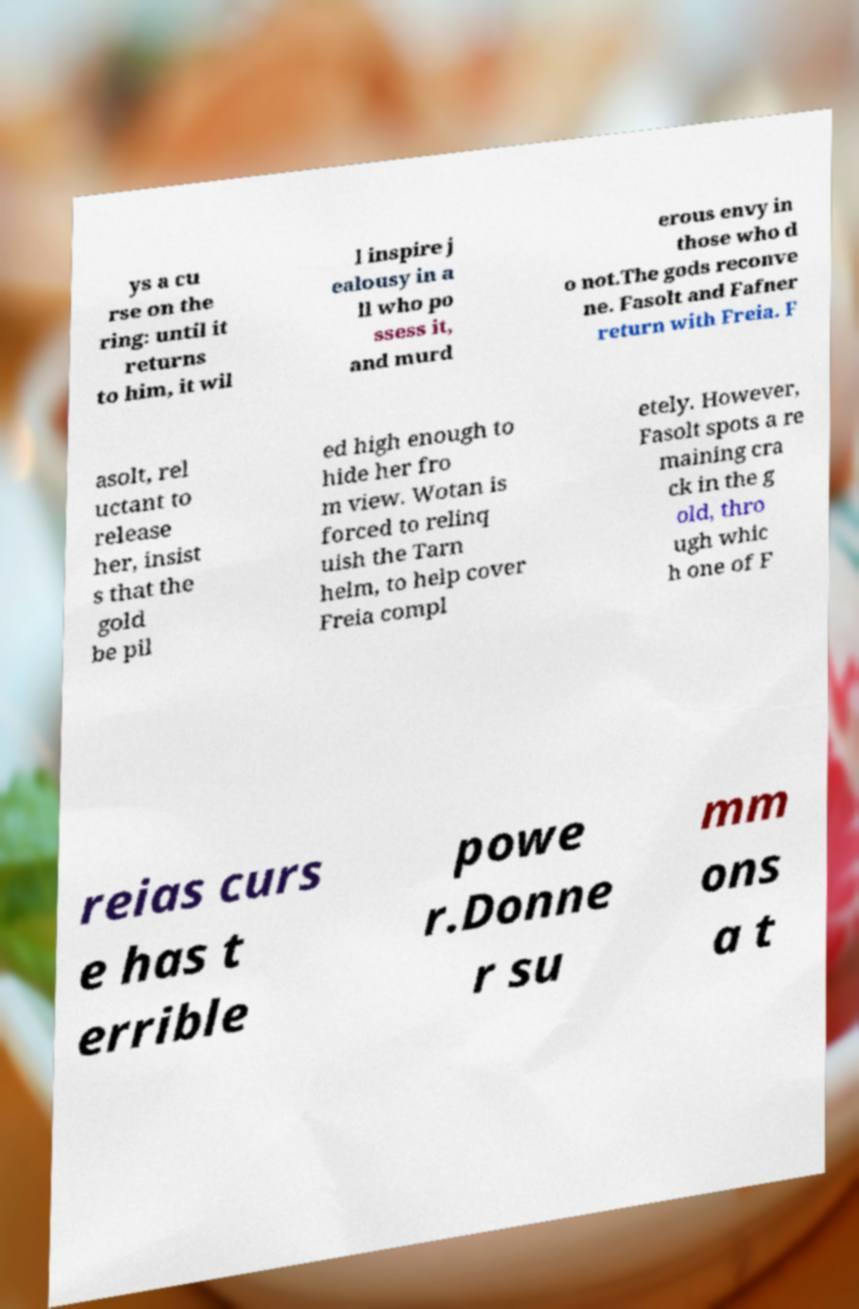I need the written content from this picture converted into text. Can you do that? ys a cu rse on the ring: until it returns to him, it wil l inspire j ealousy in a ll who po ssess it, and murd erous envy in those who d o not.The gods reconve ne. Fasolt and Fafner return with Freia. F asolt, rel uctant to release her, insist s that the gold be pil ed high enough to hide her fro m view. Wotan is forced to relinq uish the Tarn helm, to help cover Freia compl etely. However, Fasolt spots a re maining cra ck in the g old, thro ugh whic h one of F reias curs e has t errible powe r.Donne r su mm ons a t 